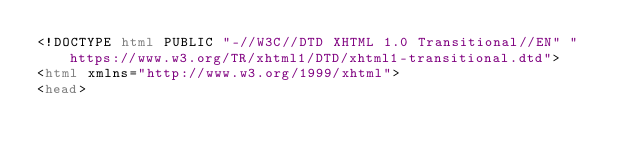Convert code to text. <code><loc_0><loc_0><loc_500><loc_500><_HTML_><!DOCTYPE html PUBLIC "-//W3C//DTD XHTML 1.0 Transitional//EN" "https://www.w3.org/TR/xhtml1/DTD/xhtml1-transitional.dtd">
<html xmlns="http://www.w3.org/1999/xhtml">
<head></code> 